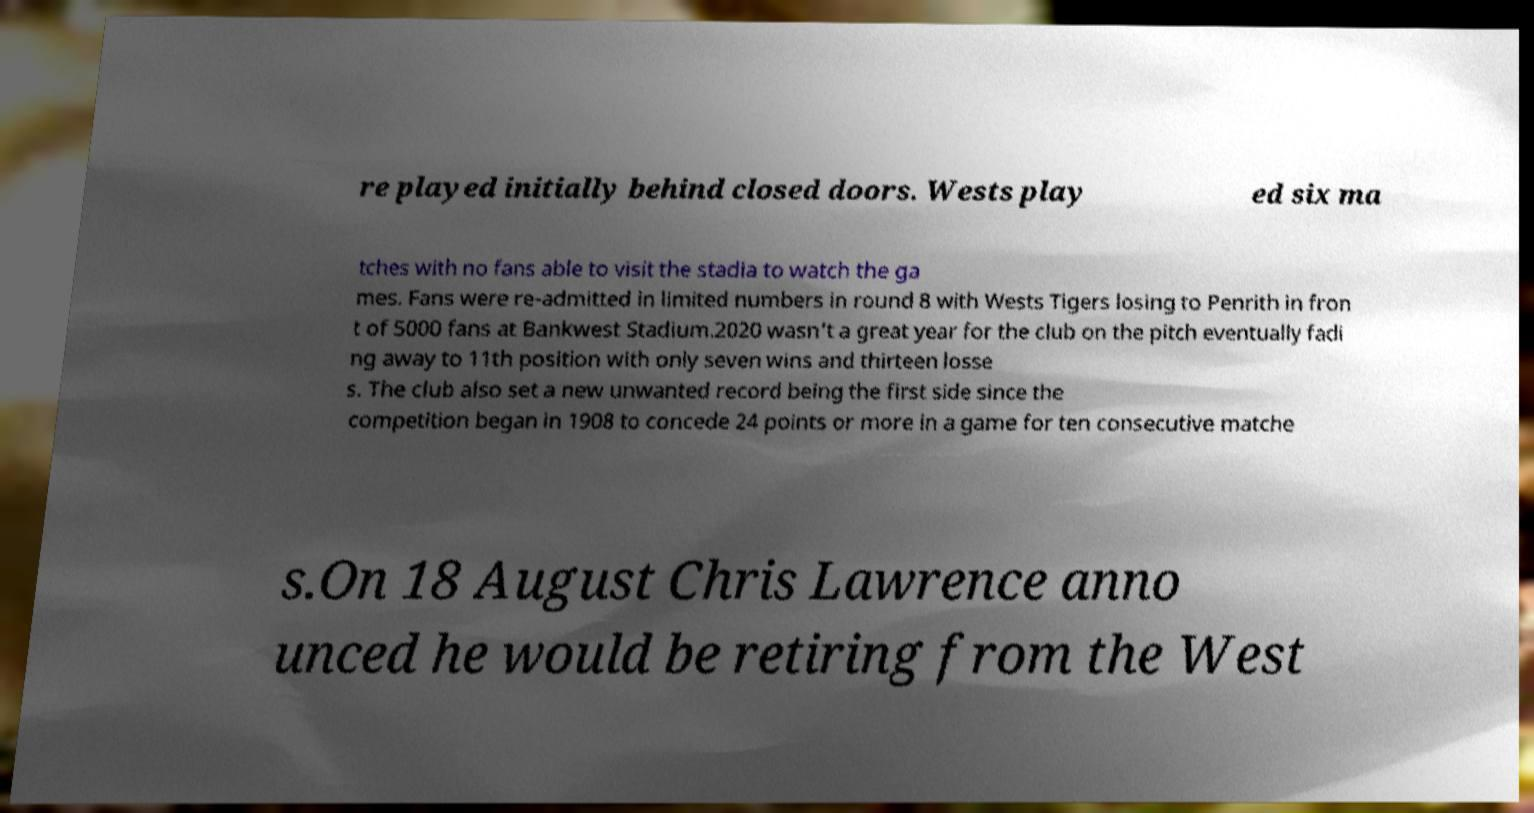For documentation purposes, I need the text within this image transcribed. Could you provide that? re played initially behind closed doors. Wests play ed six ma tches with no fans able to visit the stadia to watch the ga mes. Fans were re-admitted in limited numbers in round 8 with Wests Tigers losing to Penrith in fron t of 5000 fans at Bankwest Stadium.2020 wasn't a great year for the club on the pitch eventually fadi ng away to 11th position with only seven wins and thirteen losse s. The club also set a new unwanted record being the first side since the competition began in 1908 to concede 24 points or more in a game for ten consecutive matche s.On 18 August Chris Lawrence anno unced he would be retiring from the West 